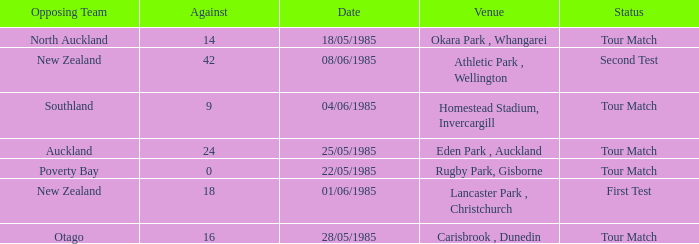Which venue had an against score smaller than 18 when the opposing team was North Auckland? Okara Park , Whangarei. 